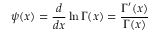<formula> <loc_0><loc_0><loc_500><loc_500>\psi ( x ) = { \frac { d } { d x } } \ln \Gamma ( x ) = { \frac { \Gamma ^ { \prime } ( x ) } { \Gamma ( x ) } }</formula> 